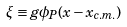<formula> <loc_0><loc_0><loc_500><loc_500>\xi \equiv g \phi _ { P } ( x - x _ { c . m . } )</formula> 